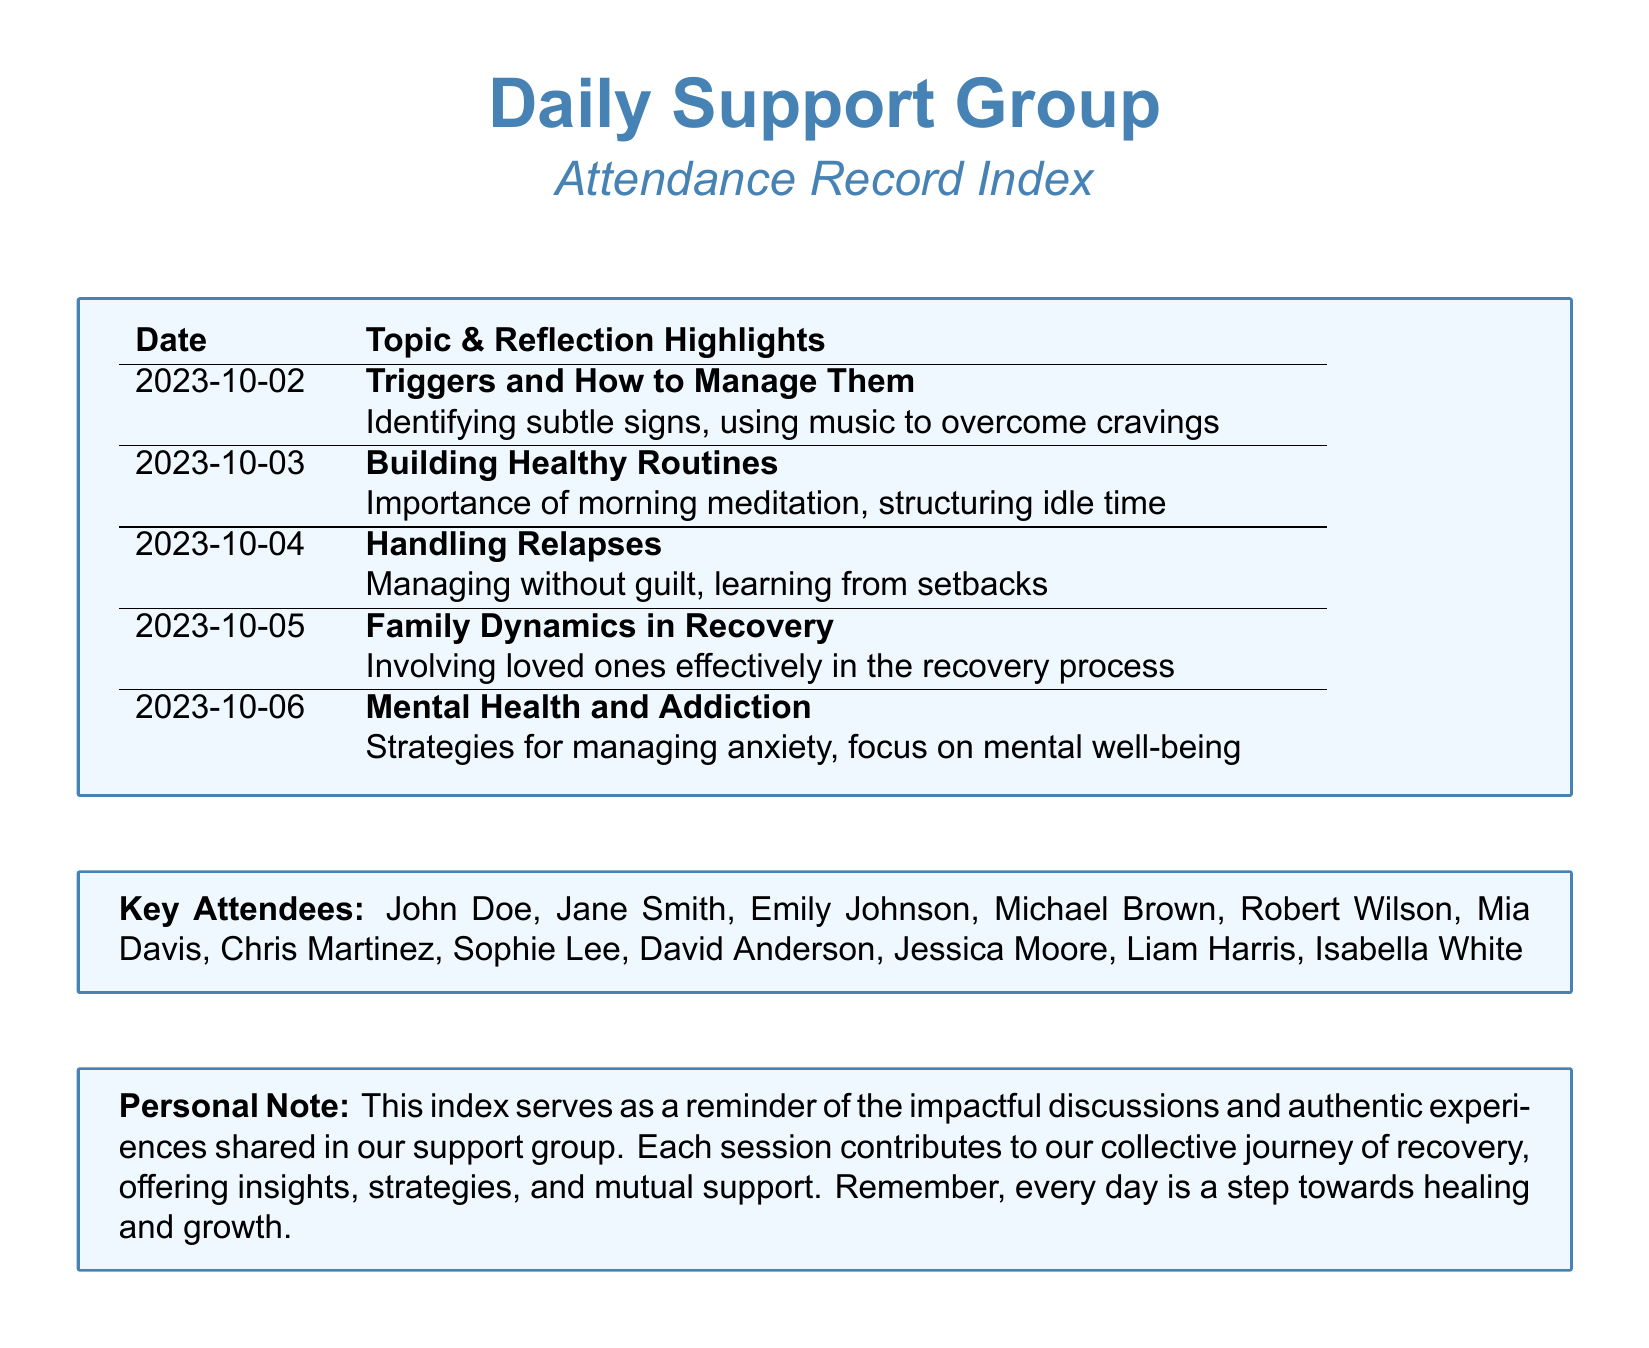What is the date of the first meeting? The first meeting listed in the document is on 2023-10-02.
Answer: 2023-10-02 What topic was discussed on 2023-10-04? The topic discussed on 2023-10-04 is "Handling Relapses."
Answer: Handling Relapses Who are the key attendees mentioned in the document? Key attendees listed include John Doe, Jane Smith, Emily Johnson, and others.
Answer: John Doe, Jane Smith, Emily Johnson, Michael Brown, Robert Wilson, Mia Davis, Chris Martinez, Sophie Lee, David Anderson, Jessica Moore, Liam Harris, Isabella White What strategy is suggested for dealing with triggers? The document suggests using music to overcome cravings as a strategy for dealing with triggers.
Answer: Using music How many total meetings are recorded in this index? There are five meetings recorded in the index based on the provided data.
Answer: 5 Which meeting discusses mental health? The meeting that discusses mental health is held on 2023-10-06.
Answer: 2023-10-06 What is the main reflection from the topic on family dynamics? The main reflection on family dynamics is about involving loved ones effectively in the recovery process.
Answer: Involving loved ones effectively What personal note is included at the end of the document? The personal note emphasizes that each session contributes to the collective journey of recovery.
Answer: Collective journey of recovery 